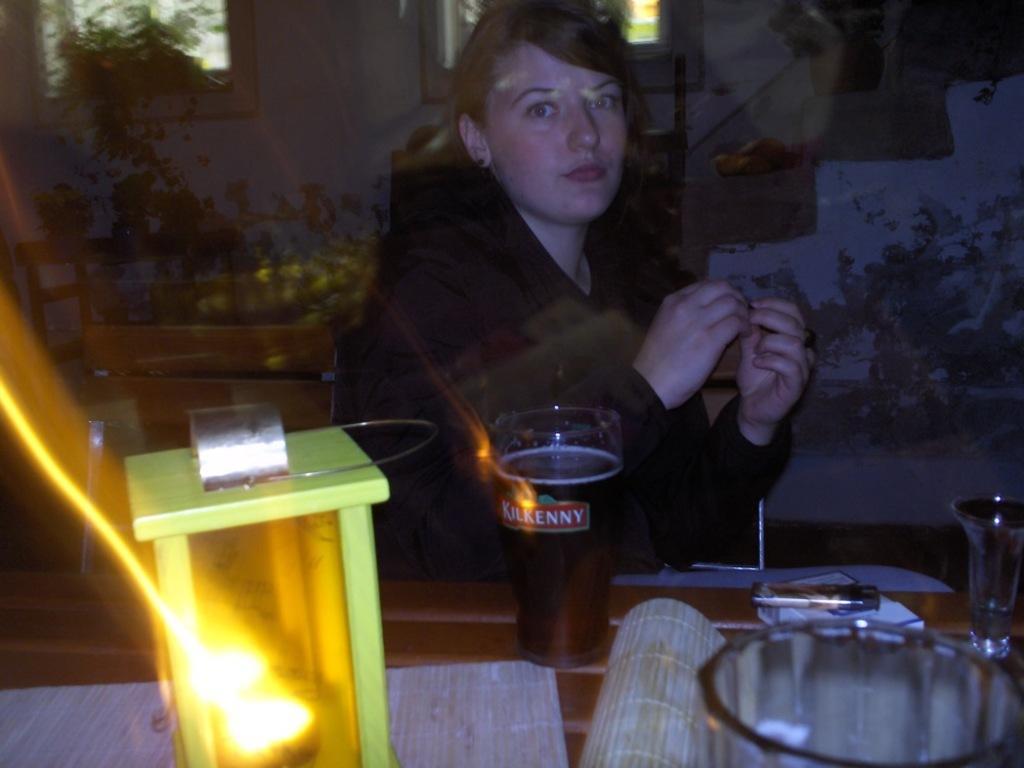Could you give a brief overview of what you see in this image? In this image I can see a woman and I can see she is wearing black colour dress. I can also see few glasses, a green colour thing, a white colour thing and here I can see something is written. 